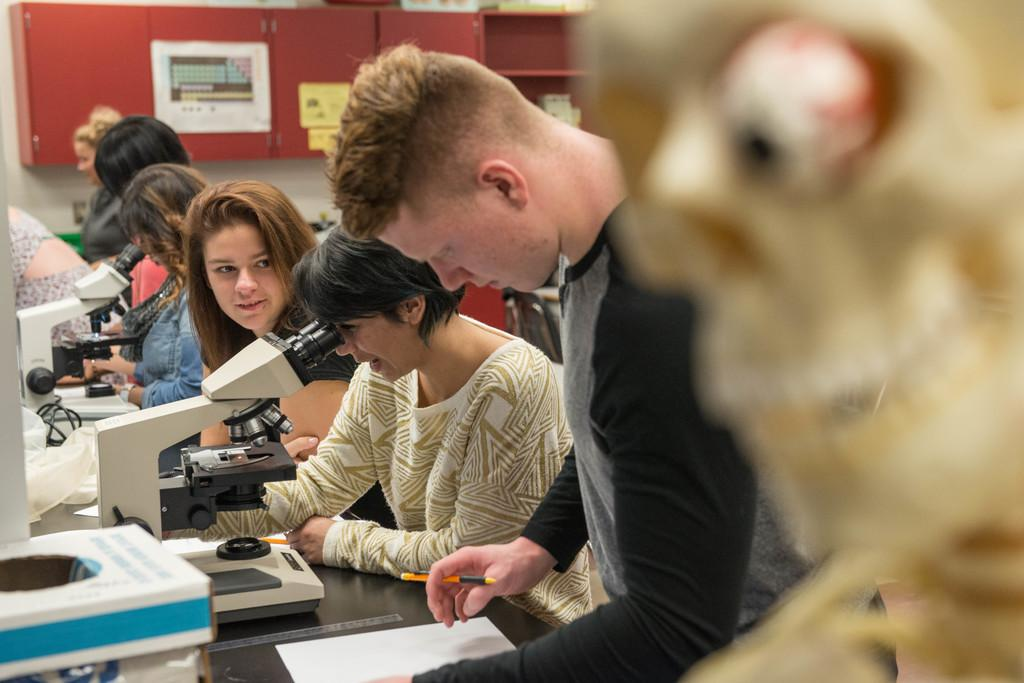What is the main subject of the image? There is a group of people in the image. What else can be seen in the image besides the people? Papers and machines on a table are present in the image. What is visible in the background of the image? There are cupboards in the background of the image. Are there any papers on the cupboards? Yes, papers are on the cupboards in the background. What type of sponge is being used by the uncle in the image? There is no sponge or uncle present in the image. How many men are visible in the image? The term "men" is not mentioned in the provided facts, so it cannot be determined from the image. 